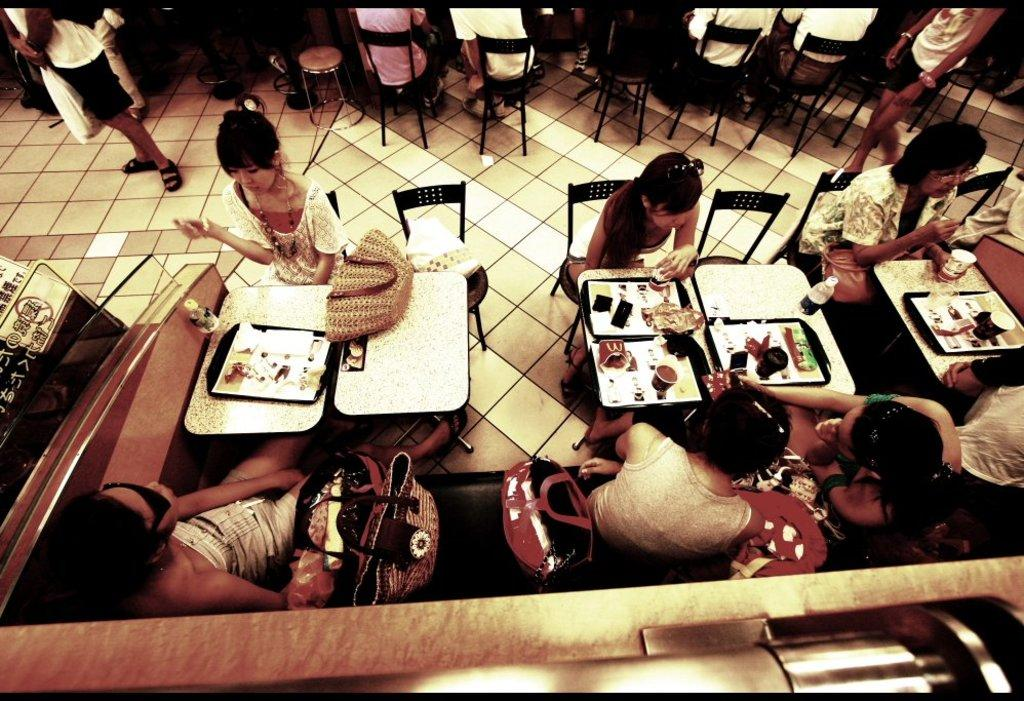What are the people in the image doing? People are sitting on the sofa and chairs in the image. What objects are in front of the people? There are tables in front of the people. What is on the tables? There are trays on the tables. What can be found on the trays? There are food items on the trays. What else is visible on the sofa? There are bags on the sofa. What type of sign can be seen hanging on the wall in the image? There is no sign visible in the image. What kind of bait is being used to catch fish in the image? There is no fishing or bait present in the image. 